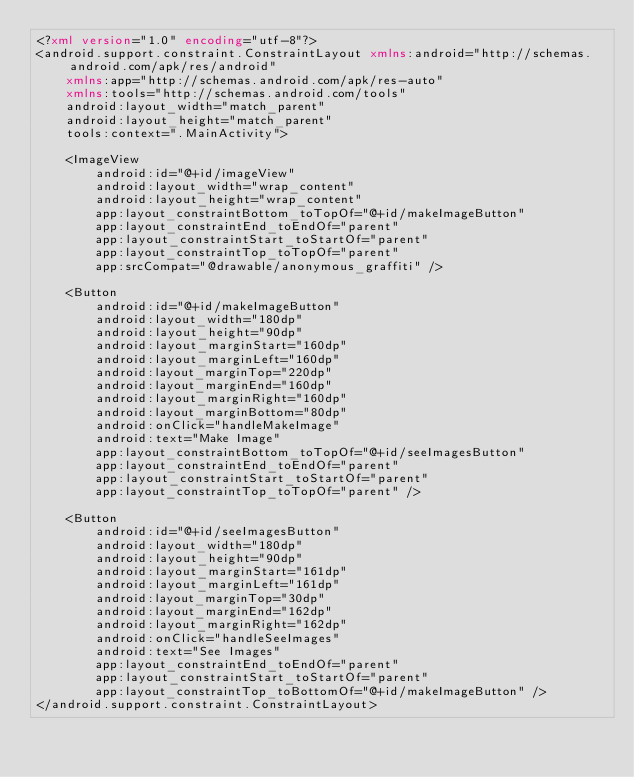<code> <loc_0><loc_0><loc_500><loc_500><_XML_><?xml version="1.0" encoding="utf-8"?>
<android.support.constraint.ConstraintLayout xmlns:android="http://schemas.android.com/apk/res/android"
    xmlns:app="http://schemas.android.com/apk/res-auto"
    xmlns:tools="http://schemas.android.com/tools"
    android:layout_width="match_parent"
    android:layout_height="match_parent"
    tools:context=".MainActivity">

    <ImageView
        android:id="@+id/imageView"
        android:layout_width="wrap_content"
        android:layout_height="wrap_content"
        app:layout_constraintBottom_toTopOf="@+id/makeImageButton"
        app:layout_constraintEnd_toEndOf="parent"
        app:layout_constraintStart_toStartOf="parent"
        app:layout_constraintTop_toTopOf="parent"
        app:srcCompat="@drawable/anonymous_graffiti" />

    <Button
        android:id="@+id/makeImageButton"
        android:layout_width="180dp"
        android:layout_height="90dp"
        android:layout_marginStart="160dp"
        android:layout_marginLeft="160dp"
        android:layout_marginTop="220dp"
        android:layout_marginEnd="160dp"
        android:layout_marginRight="160dp"
        android:layout_marginBottom="80dp"
        android:onClick="handleMakeImage"
        android:text="Make Image"
        app:layout_constraintBottom_toTopOf="@+id/seeImagesButton"
        app:layout_constraintEnd_toEndOf="parent"
        app:layout_constraintStart_toStartOf="parent"
        app:layout_constraintTop_toTopOf="parent" />

    <Button
        android:id="@+id/seeImagesButton"
        android:layout_width="180dp"
        android:layout_height="90dp"
        android:layout_marginStart="161dp"
        android:layout_marginLeft="161dp"
        android:layout_marginTop="30dp"
        android:layout_marginEnd="162dp"
        android:layout_marginRight="162dp"
        android:onClick="handleSeeImages"
        android:text="See Images"
        app:layout_constraintEnd_toEndOf="parent"
        app:layout_constraintStart_toStartOf="parent"
        app:layout_constraintTop_toBottomOf="@+id/makeImageButton" />
</android.support.constraint.ConstraintLayout></code> 